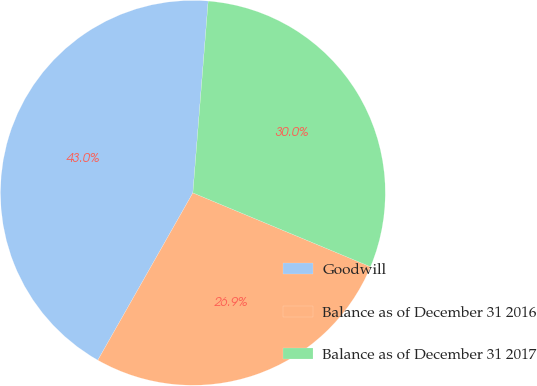<chart> <loc_0><loc_0><loc_500><loc_500><pie_chart><fcel>Goodwill<fcel>Balance as of December 31 2016<fcel>Balance as of December 31 2017<nl><fcel>43.05%<fcel>26.95%<fcel>30.01%<nl></chart> 